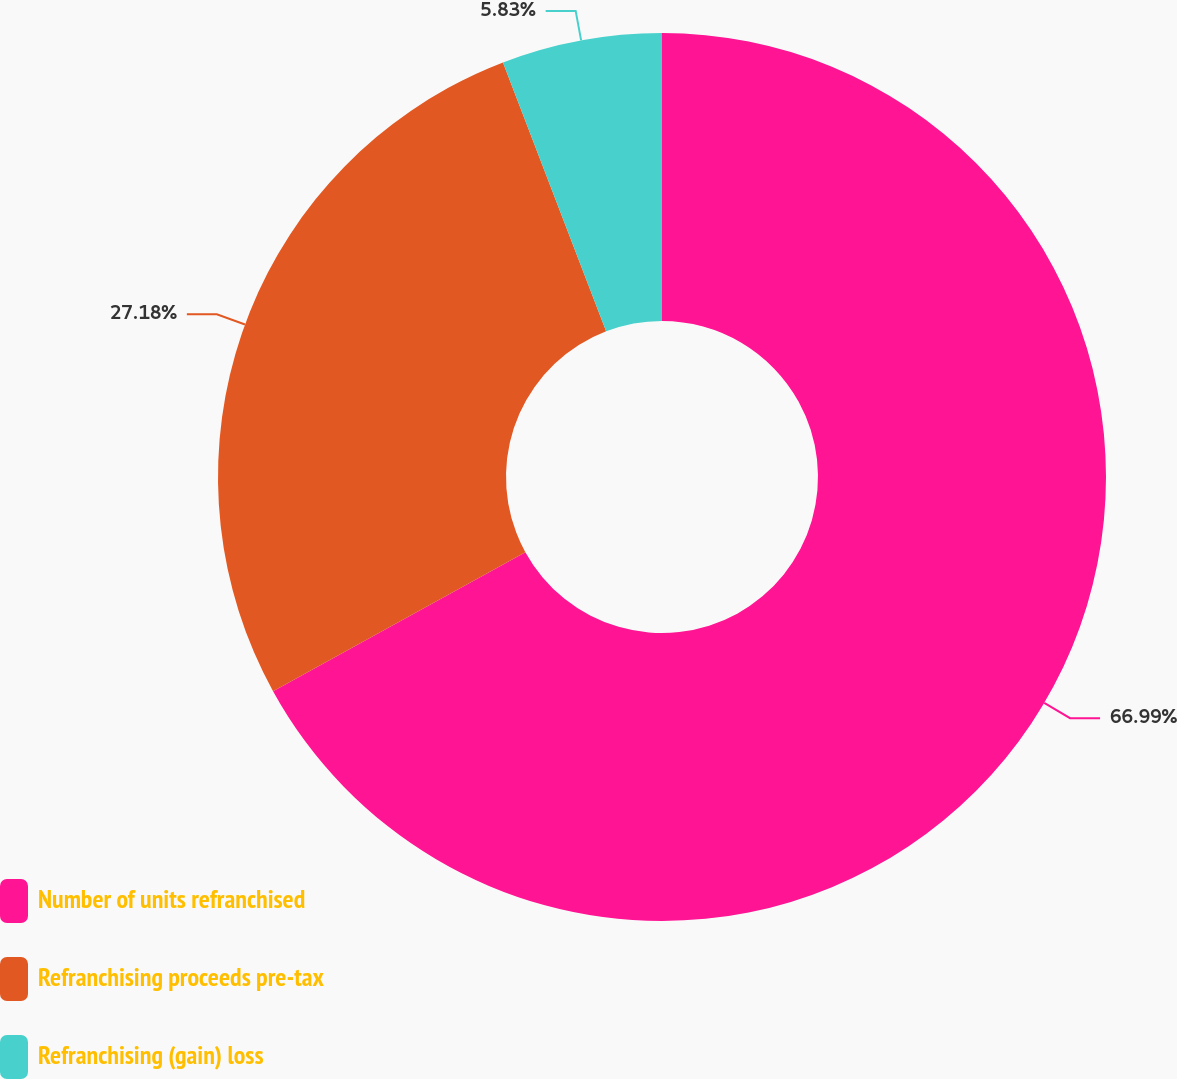<chart> <loc_0><loc_0><loc_500><loc_500><pie_chart><fcel>Number of units refranchised<fcel>Refranchising proceeds pre-tax<fcel>Refranchising (gain) loss<nl><fcel>66.99%<fcel>27.18%<fcel>5.83%<nl></chart> 